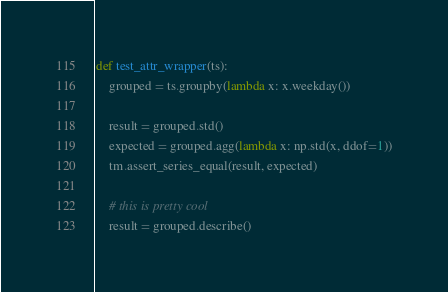Convert code to text. <code><loc_0><loc_0><loc_500><loc_500><_Python_>def test_attr_wrapper(ts):
    grouped = ts.groupby(lambda x: x.weekday())

    result = grouped.std()
    expected = grouped.agg(lambda x: np.std(x, ddof=1))
    tm.assert_series_equal(result, expected)

    # this is pretty cool
    result = grouped.describe()</code> 